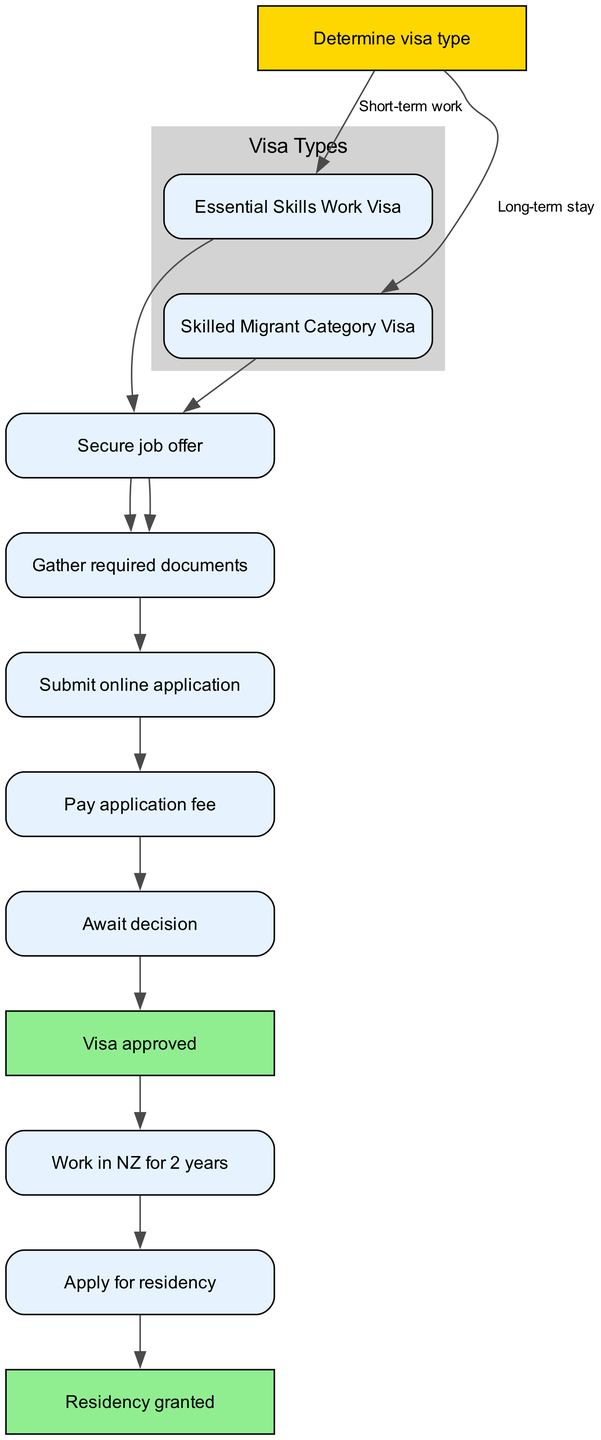What is the first step in obtaining a New Zealand work visa? The first step is represented by the node labeled "Determine visa type" which is the starting point of the flowchart.
Answer: Determine visa type How many nodes are in the diagram? By counting the nodes listed in the data, there are a total of 12 nodes present in the diagram.
Answer: 12 Which visa type is intended for long-term stay? The node labeled "Skilled Migrant Category Visa" indicates the visa type for those seeking to stay in New Zealand long-term, as per the flowchart's pathways.
Answer: Skilled Migrant Category Visa What is the final step after a work visa is approved? The last step following the approval of the work visa is "Residency granted," which signifies the conclusion of the residency application process.
Answer: Residency granted After securing a job offer, what is the next step? The next step after the "Secure job offer" node is the node labeled "Gather required documents," as this is the process that follows in the flowchart.
Answer: Gather required documents How do you begin the application process for a work visa? The application process for a work visa begins by submitting an online application, as shown in the flowchart following the preparation of documents.
Answer: Submit online application What do you need to do after paying the application fee? After paying the application fee, the next action is to "Await decision," which indicates the waiting period for the visa determination.
Answer: Await decision How long do you work in New Zealand before applying for residency? The flowchart indicates that after receiving the visa, you must work in New Zealand for 2 years before proceeding to apply for residency.
Answer: 2 years What connects the "Work in NZ for 2 years" node to the residency application? The connection from "Work in NZ for 2 years" to "Apply for residency" indicates a sequence, signifying that residency application follows after the work period is completed.
Answer: Apply for residency 